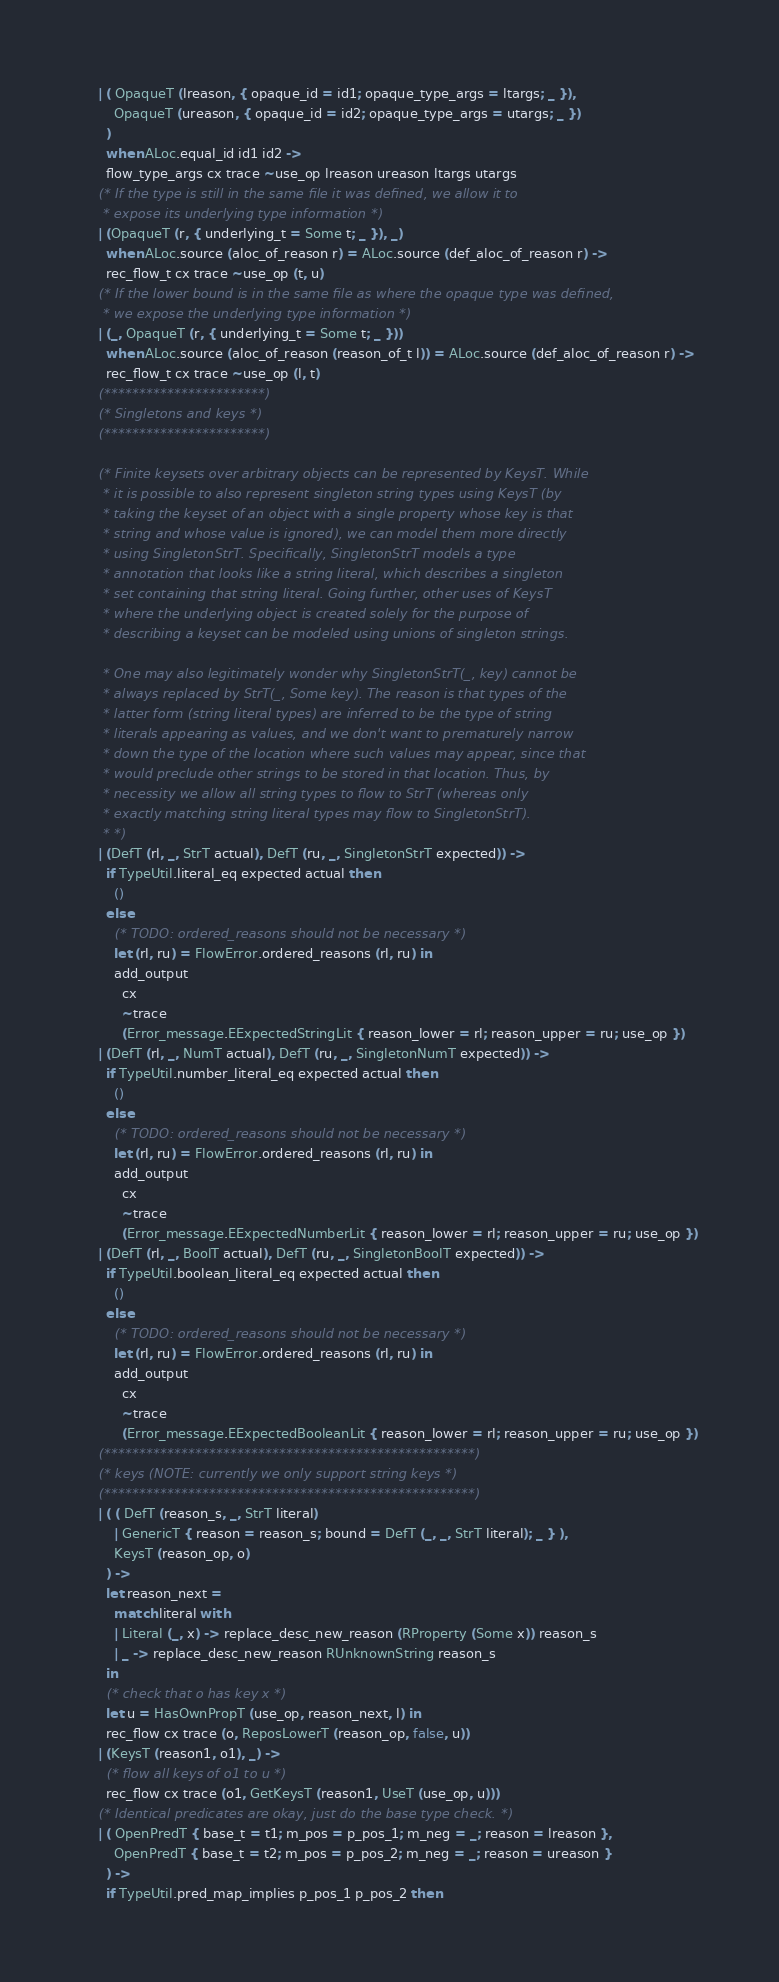<code> <loc_0><loc_0><loc_500><loc_500><_OCaml_>    | ( OpaqueT (lreason, { opaque_id = id1; opaque_type_args = ltargs; _ }),
        OpaqueT (ureason, { opaque_id = id2; opaque_type_args = utargs; _ })
      )
      when ALoc.equal_id id1 id2 ->
      flow_type_args cx trace ~use_op lreason ureason ltargs utargs
    (* If the type is still in the same file it was defined, we allow it to
     * expose its underlying type information *)
    | (OpaqueT (r, { underlying_t = Some t; _ }), _)
      when ALoc.source (aloc_of_reason r) = ALoc.source (def_aloc_of_reason r) ->
      rec_flow_t cx trace ~use_op (t, u)
    (* If the lower bound is in the same file as where the opaque type was defined,
     * we expose the underlying type information *)
    | (_, OpaqueT (r, { underlying_t = Some t; _ }))
      when ALoc.source (aloc_of_reason (reason_of_t l)) = ALoc.source (def_aloc_of_reason r) ->
      rec_flow_t cx trace ~use_op (l, t)
    (***********************)
    (* Singletons and keys *)
    (***********************)

    (* Finite keysets over arbitrary objects can be represented by KeysT. While
     * it is possible to also represent singleton string types using KeysT (by
     * taking the keyset of an object with a single property whose key is that
     * string and whose value is ignored), we can model them more directly
     * using SingletonStrT. Specifically, SingletonStrT models a type
     * annotation that looks like a string literal, which describes a singleton
     * set containing that string literal. Going further, other uses of KeysT
     * where the underlying object is created solely for the purpose of
     * describing a keyset can be modeled using unions of singleton strings.

     * One may also legitimately wonder why SingletonStrT(_, key) cannot be
     * always replaced by StrT(_, Some key). The reason is that types of the
     * latter form (string literal types) are inferred to be the type of string
     * literals appearing as values, and we don't want to prematurely narrow
     * down the type of the location where such values may appear, since that
     * would preclude other strings to be stored in that location. Thus, by
     * necessity we allow all string types to flow to StrT (whereas only
     * exactly matching string literal types may flow to SingletonStrT).
     * *)
    | (DefT (rl, _, StrT actual), DefT (ru, _, SingletonStrT expected)) ->
      if TypeUtil.literal_eq expected actual then
        ()
      else
        (* TODO: ordered_reasons should not be necessary *)
        let (rl, ru) = FlowError.ordered_reasons (rl, ru) in
        add_output
          cx
          ~trace
          (Error_message.EExpectedStringLit { reason_lower = rl; reason_upper = ru; use_op })
    | (DefT (rl, _, NumT actual), DefT (ru, _, SingletonNumT expected)) ->
      if TypeUtil.number_literal_eq expected actual then
        ()
      else
        (* TODO: ordered_reasons should not be necessary *)
        let (rl, ru) = FlowError.ordered_reasons (rl, ru) in
        add_output
          cx
          ~trace
          (Error_message.EExpectedNumberLit { reason_lower = rl; reason_upper = ru; use_op })
    | (DefT (rl, _, BoolT actual), DefT (ru, _, SingletonBoolT expected)) ->
      if TypeUtil.boolean_literal_eq expected actual then
        ()
      else
        (* TODO: ordered_reasons should not be necessary *)
        let (rl, ru) = FlowError.ordered_reasons (rl, ru) in
        add_output
          cx
          ~trace
          (Error_message.EExpectedBooleanLit { reason_lower = rl; reason_upper = ru; use_op })
    (*****************************************************)
    (* keys (NOTE: currently we only support string keys *)
    (*****************************************************)
    | ( ( DefT (reason_s, _, StrT literal)
        | GenericT { reason = reason_s; bound = DefT (_, _, StrT literal); _ } ),
        KeysT (reason_op, o)
      ) ->
      let reason_next =
        match literal with
        | Literal (_, x) -> replace_desc_new_reason (RProperty (Some x)) reason_s
        | _ -> replace_desc_new_reason RUnknownString reason_s
      in
      (* check that o has key x *)
      let u = HasOwnPropT (use_op, reason_next, l) in
      rec_flow cx trace (o, ReposLowerT (reason_op, false, u))
    | (KeysT (reason1, o1), _) ->
      (* flow all keys of o1 to u *)
      rec_flow cx trace (o1, GetKeysT (reason1, UseT (use_op, u)))
    (* Identical predicates are okay, just do the base type check. *)
    | ( OpenPredT { base_t = t1; m_pos = p_pos_1; m_neg = _; reason = lreason },
        OpenPredT { base_t = t2; m_pos = p_pos_2; m_neg = _; reason = ureason }
      ) ->
      if TypeUtil.pred_map_implies p_pos_1 p_pos_2 then</code> 